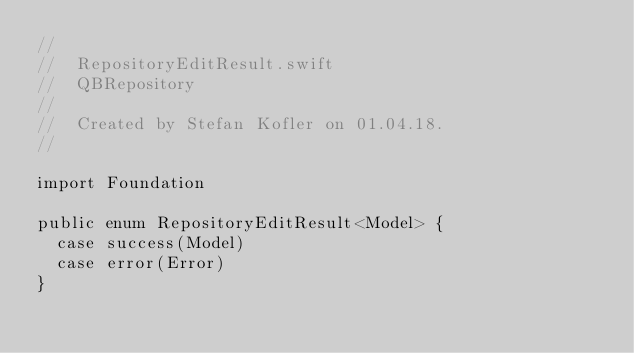<code> <loc_0><loc_0><loc_500><loc_500><_Swift_>//
//  RepositoryEditResult.swift
//  QBRepository
//
//  Created by Stefan Kofler on 01.04.18.
//

import Foundation

public enum RepositoryEditResult<Model> {
  case success(Model)
  case error(Error)
}
</code> 